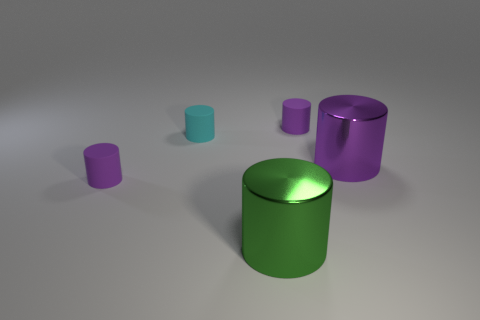How big is the purple matte object on the right side of the cyan rubber thing?
Your answer should be compact. Small. How many large green cylinders have the same material as the large purple object?
Make the answer very short. 1. There is a tiny matte thing on the left side of the tiny cyan cylinder; is its shape the same as the tiny cyan thing?
Offer a terse response. Yes. There is a small purple thing to the right of the green thing; what shape is it?
Give a very brief answer. Cylinder. What material is the large green cylinder?
Ensure brevity in your answer.  Metal. There is another shiny thing that is the same size as the green object; what color is it?
Provide a succinct answer. Purple. Is the shape of the cyan thing the same as the big purple shiny thing?
Ensure brevity in your answer.  Yes. What material is the thing that is both in front of the cyan thing and left of the big green cylinder?
Your response must be concise. Rubber. How big is the cyan object?
Your answer should be compact. Small. The other large thing that is the same shape as the purple metal thing is what color?
Give a very brief answer. Green. 